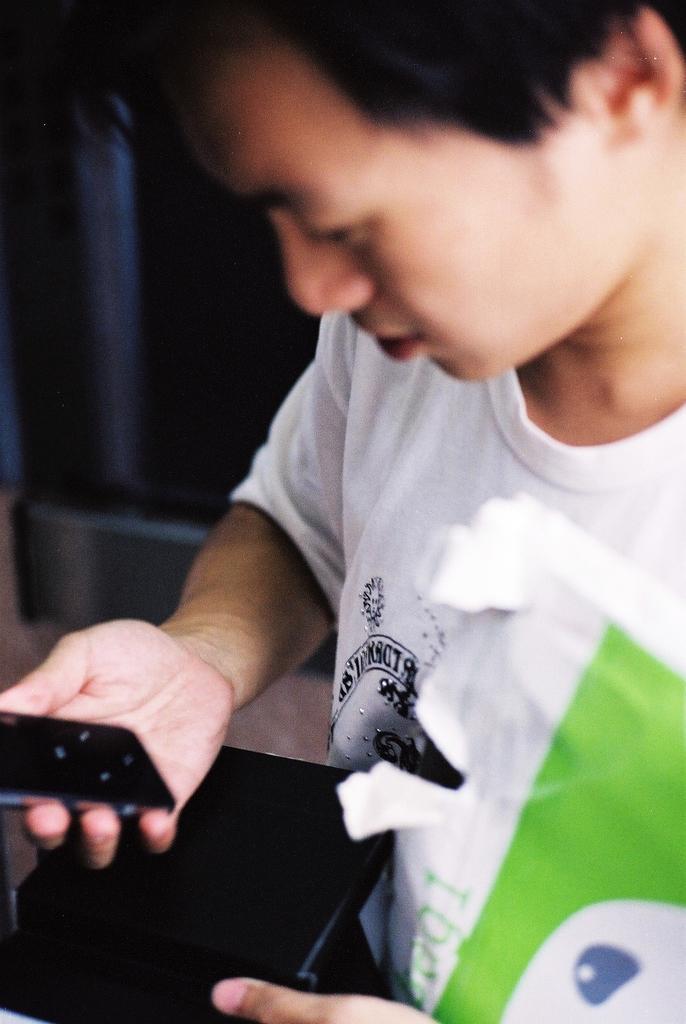How would you summarize this image in a sentence or two? In the picture ,a man wearing white shirt is holding mobile phone in his hand in his left hand he is holding a file. 